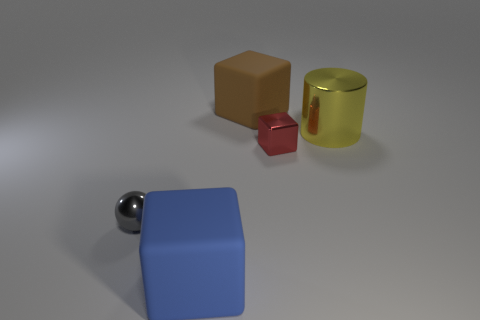Add 5 small purple metallic cubes. How many objects exist? 10 Subtract all blocks. How many objects are left? 2 Add 3 brown things. How many brown things exist? 4 Subtract 0 green spheres. How many objects are left? 5 Subtract all brown blocks. Subtract all blue objects. How many objects are left? 3 Add 5 big shiny objects. How many big shiny objects are left? 6 